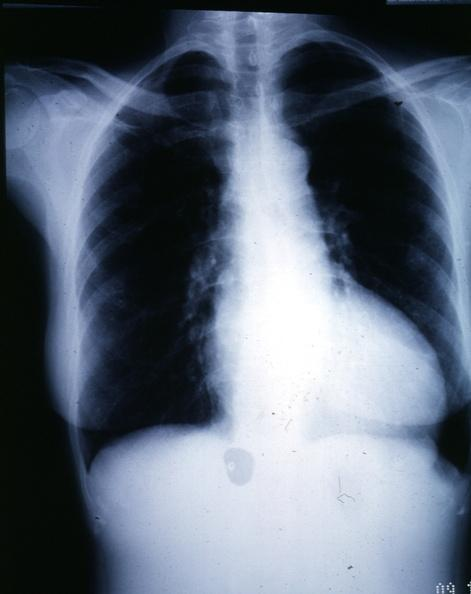s leiomyosarcoma present?
Answer the question using a single word or phrase. No 